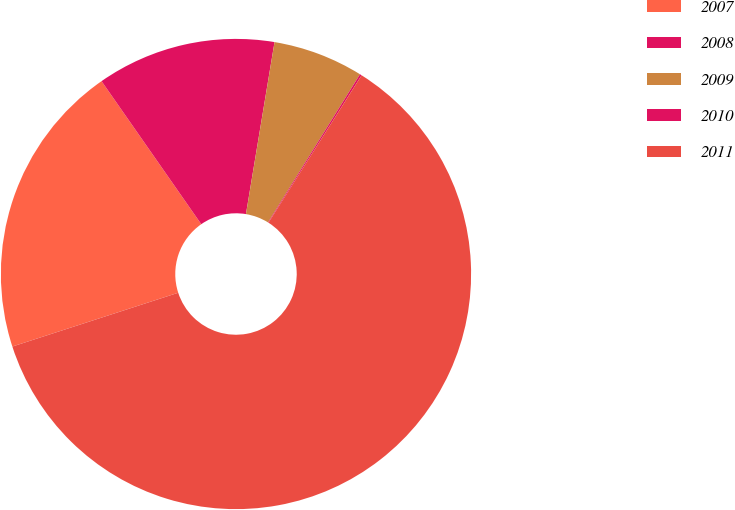<chart> <loc_0><loc_0><loc_500><loc_500><pie_chart><fcel>2007<fcel>2008<fcel>2009<fcel>2010<fcel>2011<nl><fcel>20.3%<fcel>12.31%<fcel>6.22%<fcel>0.13%<fcel>61.03%<nl></chart> 